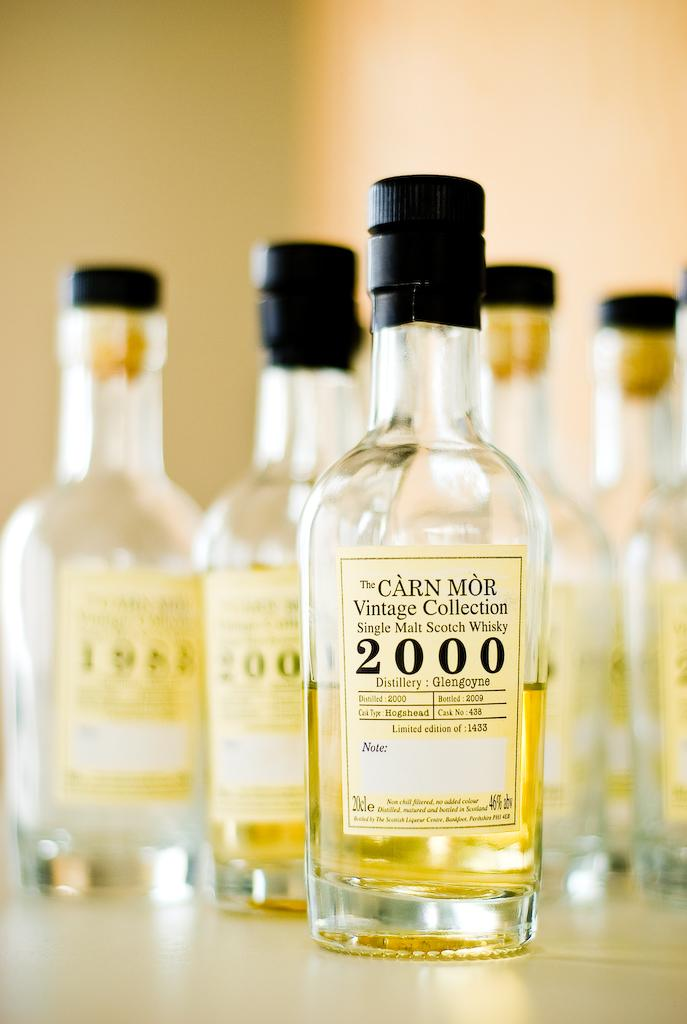<image>
Write a terse but informative summary of the picture. A scotch with 2000 written on the label sits with others on the table 